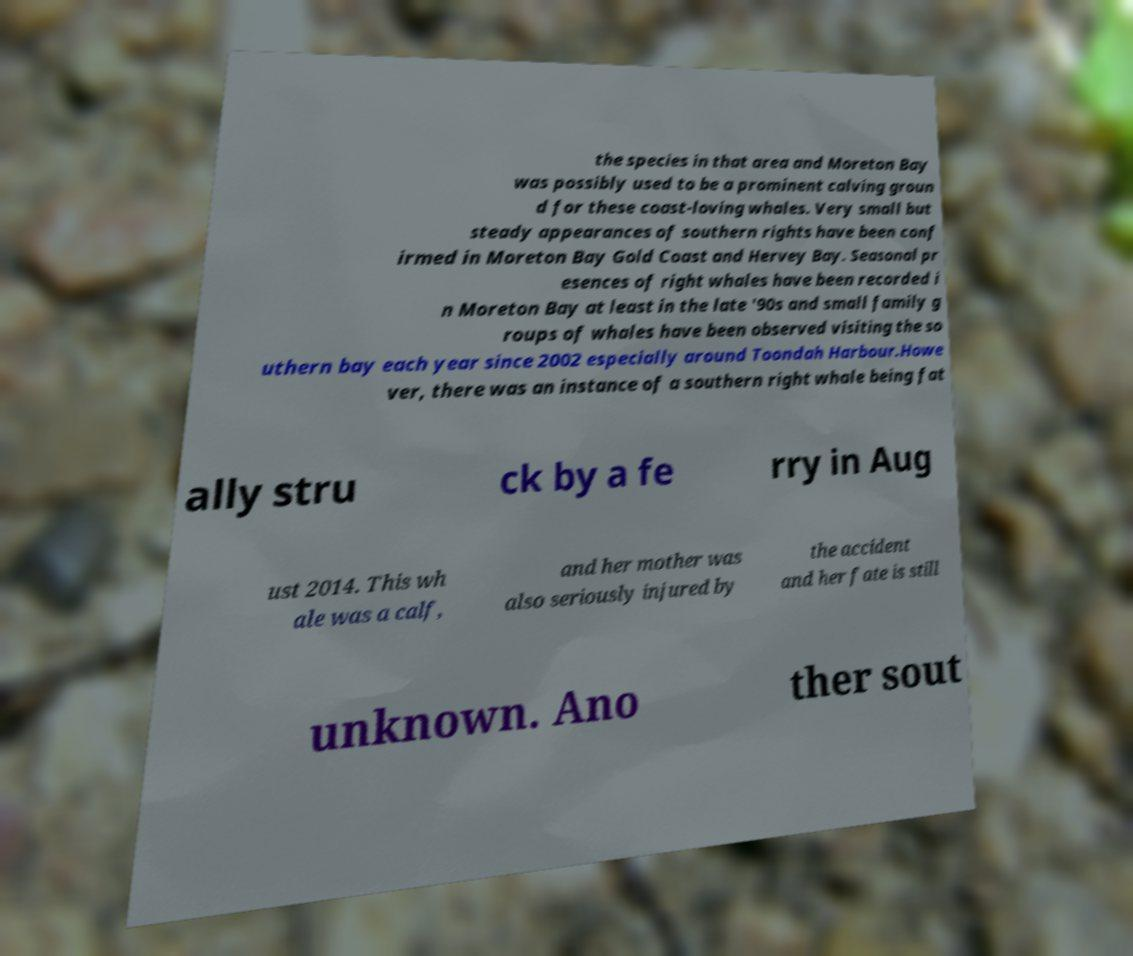Could you assist in decoding the text presented in this image and type it out clearly? the species in that area and Moreton Bay was possibly used to be a prominent calving groun d for these coast-loving whales. Very small but steady appearances of southern rights have been conf irmed in Moreton Bay Gold Coast and Hervey Bay. Seasonal pr esences of right whales have been recorded i n Moreton Bay at least in the late '90s and small family g roups of whales have been observed visiting the so uthern bay each year since 2002 especially around Toondah Harbour.Howe ver, there was an instance of a southern right whale being fat ally stru ck by a fe rry in Aug ust 2014. This wh ale was a calf, and her mother was also seriously injured by the accident and her fate is still unknown. Ano ther sout 